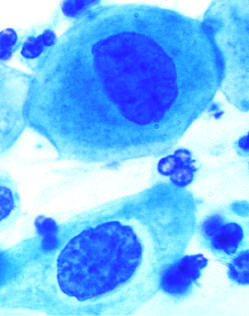does this observation reflect the progressive loss of cellular differentiation on the surface of the cervical lesions from which these cells are exfoliated?
Answer the question using a single word or phrase. Yes 